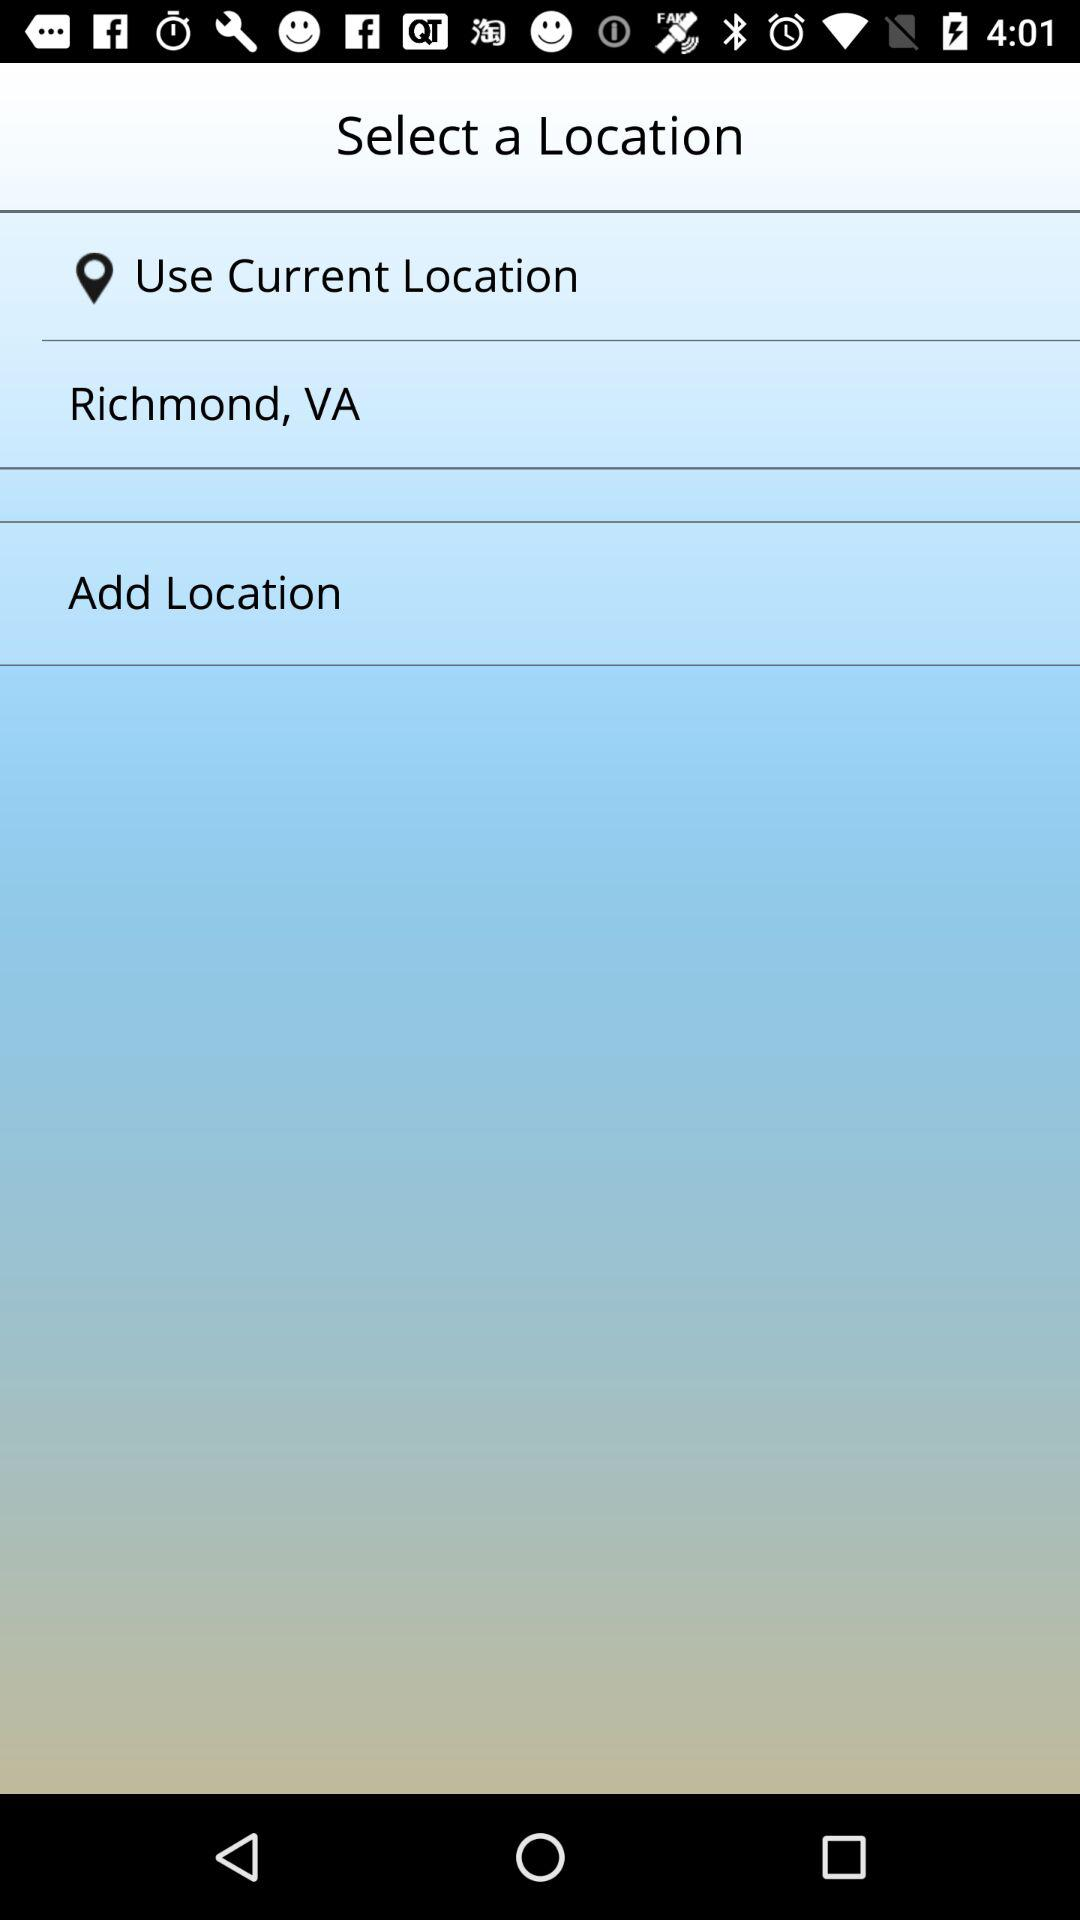What is the location given? The location is Richmond, VA. 